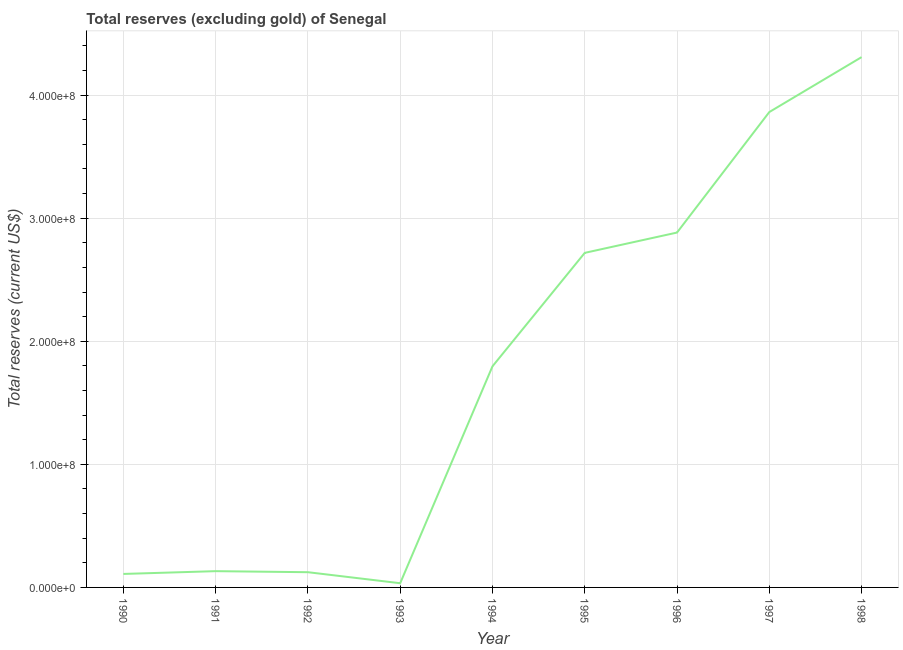What is the total reserves (excluding gold) in 1991?
Ensure brevity in your answer.  1.32e+07. Across all years, what is the maximum total reserves (excluding gold)?
Your answer should be compact. 4.31e+08. Across all years, what is the minimum total reserves (excluding gold)?
Keep it short and to the point. 3.41e+06. In which year was the total reserves (excluding gold) minimum?
Keep it short and to the point. 1993. What is the sum of the total reserves (excluding gold)?
Provide a succinct answer. 1.60e+09. What is the difference between the total reserves (excluding gold) in 1990 and 1995?
Provide a short and direct response. -2.61e+08. What is the average total reserves (excluding gold) per year?
Keep it short and to the point. 1.77e+08. What is the median total reserves (excluding gold)?
Your answer should be very brief. 1.80e+08. Do a majority of the years between 1990 and 1997 (inclusive) have total reserves (excluding gold) greater than 20000000 US$?
Your answer should be compact. No. What is the ratio of the total reserves (excluding gold) in 1994 to that in 1996?
Keep it short and to the point. 0.62. What is the difference between the highest and the second highest total reserves (excluding gold)?
Ensure brevity in your answer.  4.46e+07. Is the sum of the total reserves (excluding gold) in 1994 and 1995 greater than the maximum total reserves (excluding gold) across all years?
Provide a short and direct response. Yes. What is the difference between the highest and the lowest total reserves (excluding gold)?
Ensure brevity in your answer.  4.27e+08. How many lines are there?
Offer a terse response. 1. How many years are there in the graph?
Ensure brevity in your answer.  9. What is the difference between two consecutive major ticks on the Y-axis?
Make the answer very short. 1.00e+08. Are the values on the major ticks of Y-axis written in scientific E-notation?
Your answer should be very brief. Yes. What is the title of the graph?
Provide a short and direct response. Total reserves (excluding gold) of Senegal. What is the label or title of the Y-axis?
Your answer should be compact. Total reserves (current US$). What is the Total reserves (current US$) in 1990?
Offer a very short reply. 1.10e+07. What is the Total reserves (current US$) in 1991?
Make the answer very short. 1.32e+07. What is the Total reserves (current US$) in 1992?
Provide a short and direct response. 1.24e+07. What is the Total reserves (current US$) of 1993?
Offer a very short reply. 3.41e+06. What is the Total reserves (current US$) of 1994?
Your answer should be very brief. 1.80e+08. What is the Total reserves (current US$) of 1995?
Your answer should be compact. 2.72e+08. What is the Total reserves (current US$) in 1996?
Your answer should be compact. 2.88e+08. What is the Total reserves (current US$) in 1997?
Your answer should be very brief. 3.86e+08. What is the Total reserves (current US$) in 1998?
Give a very brief answer. 4.31e+08. What is the difference between the Total reserves (current US$) in 1990 and 1991?
Provide a short and direct response. -2.26e+06. What is the difference between the Total reserves (current US$) in 1990 and 1992?
Offer a terse response. -1.41e+06. What is the difference between the Total reserves (current US$) in 1990 and 1993?
Provide a succinct answer. 7.54e+06. What is the difference between the Total reserves (current US$) in 1990 and 1994?
Offer a terse response. -1.69e+08. What is the difference between the Total reserves (current US$) in 1990 and 1995?
Provide a short and direct response. -2.61e+08. What is the difference between the Total reserves (current US$) in 1990 and 1996?
Keep it short and to the point. -2.77e+08. What is the difference between the Total reserves (current US$) in 1990 and 1997?
Provide a succinct answer. -3.75e+08. What is the difference between the Total reserves (current US$) in 1990 and 1998?
Provide a short and direct response. -4.20e+08. What is the difference between the Total reserves (current US$) in 1991 and 1992?
Offer a very short reply. 8.44e+05. What is the difference between the Total reserves (current US$) in 1991 and 1993?
Ensure brevity in your answer.  9.80e+06. What is the difference between the Total reserves (current US$) in 1991 and 1994?
Ensure brevity in your answer.  -1.66e+08. What is the difference between the Total reserves (current US$) in 1991 and 1995?
Keep it short and to the point. -2.59e+08. What is the difference between the Total reserves (current US$) in 1991 and 1996?
Provide a succinct answer. -2.75e+08. What is the difference between the Total reserves (current US$) in 1991 and 1997?
Keep it short and to the point. -3.73e+08. What is the difference between the Total reserves (current US$) in 1991 and 1998?
Your answer should be compact. -4.18e+08. What is the difference between the Total reserves (current US$) in 1992 and 1993?
Your answer should be very brief. 8.96e+06. What is the difference between the Total reserves (current US$) in 1992 and 1994?
Offer a terse response. -1.67e+08. What is the difference between the Total reserves (current US$) in 1992 and 1995?
Provide a short and direct response. -2.59e+08. What is the difference between the Total reserves (current US$) in 1992 and 1996?
Ensure brevity in your answer.  -2.76e+08. What is the difference between the Total reserves (current US$) in 1992 and 1997?
Provide a short and direct response. -3.74e+08. What is the difference between the Total reserves (current US$) in 1992 and 1998?
Offer a very short reply. -4.18e+08. What is the difference between the Total reserves (current US$) in 1993 and 1994?
Keep it short and to the point. -1.76e+08. What is the difference between the Total reserves (current US$) in 1993 and 1995?
Your response must be concise. -2.68e+08. What is the difference between the Total reserves (current US$) in 1993 and 1996?
Make the answer very short. -2.85e+08. What is the difference between the Total reserves (current US$) in 1993 and 1997?
Keep it short and to the point. -3.83e+08. What is the difference between the Total reserves (current US$) in 1993 and 1998?
Provide a succinct answer. -4.27e+08. What is the difference between the Total reserves (current US$) in 1994 and 1995?
Your answer should be compact. -9.22e+07. What is the difference between the Total reserves (current US$) in 1994 and 1996?
Your response must be concise. -1.09e+08. What is the difference between the Total reserves (current US$) in 1994 and 1997?
Give a very brief answer. -2.07e+08. What is the difference between the Total reserves (current US$) in 1994 and 1998?
Offer a terse response. -2.51e+08. What is the difference between the Total reserves (current US$) in 1995 and 1996?
Provide a short and direct response. -1.65e+07. What is the difference between the Total reserves (current US$) in 1995 and 1997?
Ensure brevity in your answer.  -1.14e+08. What is the difference between the Total reserves (current US$) in 1995 and 1998?
Ensure brevity in your answer.  -1.59e+08. What is the difference between the Total reserves (current US$) in 1996 and 1997?
Your response must be concise. -9.79e+07. What is the difference between the Total reserves (current US$) in 1996 and 1998?
Your answer should be compact. -1.43e+08. What is the difference between the Total reserves (current US$) in 1997 and 1998?
Make the answer very short. -4.46e+07. What is the ratio of the Total reserves (current US$) in 1990 to that in 1991?
Ensure brevity in your answer.  0.83. What is the ratio of the Total reserves (current US$) in 1990 to that in 1992?
Your response must be concise. 0.89. What is the ratio of the Total reserves (current US$) in 1990 to that in 1993?
Keep it short and to the point. 3.21. What is the ratio of the Total reserves (current US$) in 1990 to that in 1994?
Offer a very short reply. 0.06. What is the ratio of the Total reserves (current US$) in 1990 to that in 1995?
Your answer should be very brief. 0.04. What is the ratio of the Total reserves (current US$) in 1990 to that in 1996?
Offer a very short reply. 0.04. What is the ratio of the Total reserves (current US$) in 1990 to that in 1997?
Keep it short and to the point. 0.03. What is the ratio of the Total reserves (current US$) in 1990 to that in 1998?
Offer a terse response. 0.03. What is the ratio of the Total reserves (current US$) in 1991 to that in 1992?
Your answer should be compact. 1.07. What is the ratio of the Total reserves (current US$) in 1991 to that in 1993?
Your answer should be very brief. 3.87. What is the ratio of the Total reserves (current US$) in 1991 to that in 1994?
Provide a short and direct response. 0.07. What is the ratio of the Total reserves (current US$) in 1991 to that in 1995?
Your response must be concise. 0.05. What is the ratio of the Total reserves (current US$) in 1991 to that in 1996?
Ensure brevity in your answer.  0.05. What is the ratio of the Total reserves (current US$) in 1991 to that in 1997?
Ensure brevity in your answer.  0.03. What is the ratio of the Total reserves (current US$) in 1991 to that in 1998?
Make the answer very short. 0.03. What is the ratio of the Total reserves (current US$) in 1992 to that in 1993?
Offer a very short reply. 3.62. What is the ratio of the Total reserves (current US$) in 1992 to that in 1994?
Give a very brief answer. 0.07. What is the ratio of the Total reserves (current US$) in 1992 to that in 1995?
Your answer should be compact. 0.05. What is the ratio of the Total reserves (current US$) in 1992 to that in 1996?
Provide a short and direct response. 0.04. What is the ratio of the Total reserves (current US$) in 1992 to that in 1997?
Provide a succinct answer. 0.03. What is the ratio of the Total reserves (current US$) in 1992 to that in 1998?
Your answer should be very brief. 0.03. What is the ratio of the Total reserves (current US$) in 1993 to that in 1994?
Your response must be concise. 0.02. What is the ratio of the Total reserves (current US$) in 1993 to that in 1995?
Make the answer very short. 0.01. What is the ratio of the Total reserves (current US$) in 1993 to that in 1996?
Your answer should be very brief. 0.01. What is the ratio of the Total reserves (current US$) in 1993 to that in 1997?
Offer a very short reply. 0.01. What is the ratio of the Total reserves (current US$) in 1993 to that in 1998?
Keep it short and to the point. 0.01. What is the ratio of the Total reserves (current US$) in 1994 to that in 1995?
Ensure brevity in your answer.  0.66. What is the ratio of the Total reserves (current US$) in 1994 to that in 1996?
Your response must be concise. 0.62. What is the ratio of the Total reserves (current US$) in 1994 to that in 1997?
Make the answer very short. 0.47. What is the ratio of the Total reserves (current US$) in 1994 to that in 1998?
Keep it short and to the point. 0.42. What is the ratio of the Total reserves (current US$) in 1995 to that in 1996?
Your answer should be very brief. 0.94. What is the ratio of the Total reserves (current US$) in 1995 to that in 1997?
Ensure brevity in your answer.  0.7. What is the ratio of the Total reserves (current US$) in 1995 to that in 1998?
Offer a very short reply. 0.63. What is the ratio of the Total reserves (current US$) in 1996 to that in 1997?
Provide a short and direct response. 0.75. What is the ratio of the Total reserves (current US$) in 1996 to that in 1998?
Ensure brevity in your answer.  0.67. What is the ratio of the Total reserves (current US$) in 1997 to that in 1998?
Give a very brief answer. 0.9. 